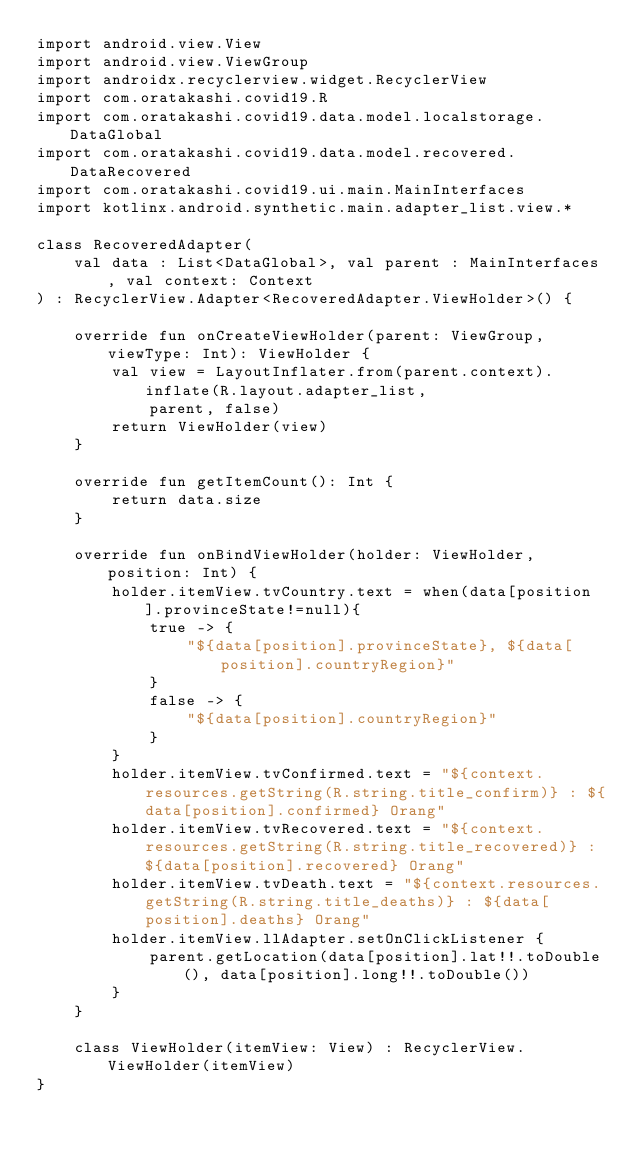Convert code to text. <code><loc_0><loc_0><loc_500><loc_500><_Kotlin_>import android.view.View
import android.view.ViewGroup
import androidx.recyclerview.widget.RecyclerView
import com.oratakashi.covid19.R
import com.oratakashi.covid19.data.model.localstorage.DataGlobal
import com.oratakashi.covid19.data.model.recovered.DataRecovered
import com.oratakashi.covid19.ui.main.MainInterfaces
import kotlinx.android.synthetic.main.adapter_list.view.*

class RecoveredAdapter(
    val data : List<DataGlobal>, val parent : MainInterfaces, val context: Context
) : RecyclerView.Adapter<RecoveredAdapter.ViewHolder>() {

    override fun onCreateViewHolder(parent: ViewGroup, viewType: Int): ViewHolder {
        val view = LayoutInflater.from(parent.context).inflate(R.layout.adapter_list,
            parent, false)
        return ViewHolder(view)
    }

    override fun getItemCount(): Int {
        return data.size
    }

    override fun onBindViewHolder(holder: ViewHolder, position: Int) {
        holder.itemView.tvCountry.text = when(data[position].provinceState!=null){
            true -> {
                "${data[position].provinceState}, ${data[position].countryRegion}"
            }
            false -> {
                "${data[position].countryRegion}"
            }
        }
        holder.itemView.tvConfirmed.text = "${context.resources.getString(R.string.title_confirm)} : ${data[position].confirmed} Orang"
        holder.itemView.tvRecovered.text = "${context.resources.getString(R.string.title_recovered)} : ${data[position].recovered} Orang"
        holder.itemView.tvDeath.text = "${context.resources.getString(R.string.title_deaths)} : ${data[position].deaths} Orang"
        holder.itemView.llAdapter.setOnClickListener {
            parent.getLocation(data[position].lat!!.toDouble(), data[position].long!!.toDouble())
        }
    }

    class ViewHolder(itemView: View) : RecyclerView.ViewHolder(itemView)
}</code> 